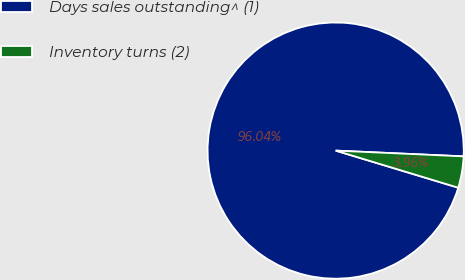Convert chart to OTSL. <chart><loc_0><loc_0><loc_500><loc_500><pie_chart><fcel>Days sales outstanding^ (1)<fcel>Inventory turns (2)<nl><fcel>96.04%<fcel>3.96%<nl></chart> 